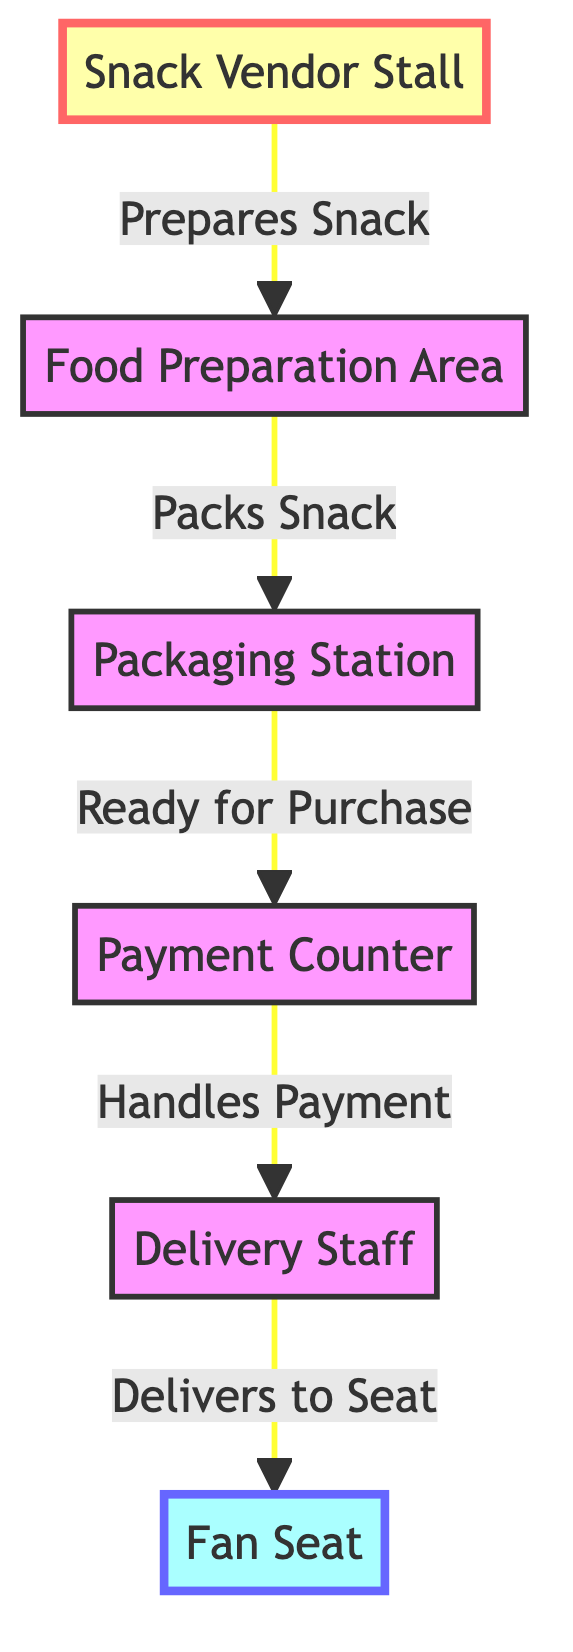What is the first step in the snack preparation process? The first step is "Prepares Snack," where the Snack Vendor Stall prepares the snack.
Answer: Prepares Snack How many nodes are in the diagram? The diagram consists of 6 nodes: Snack Vendor Stall, Food Preparation Area, Packaging Station, Payment Counter, Delivery Staff, and Fan Seat.
Answer: 6 What role does the Delivery Staff play in the process? The Delivery Staff's role is to "Delivers to Seat," referring to delivering the packed snack to the fan's seat.
Answer: Delivers to Seat What comes after the Packaging Station in the workflow? After the Packaging Station, the workflow leads to the Payment Counter, indicating the next step after packing.
Answer: Payment Counter What is the final destination in the snack journey? The final destination in the snack journey is the Fan Seat, where the fan receives the snack.
Answer: Fan Seat What is the relationship between the Vendor and the Food Preparation Area? The relationship is that the Vendor "Prepares Snack" in the Food Preparation Area, indicating a direct action from the vendor to this area.
Answer: Prepares Snack What is packaged before reaching the Payment Counter? The item that is packaged before reaching the Payment Counter is the snack, which is ready for purchase at that point.
Answer: Snack What does the diagram illustrate regarding matchday snacks? The diagram illustrates the flow of a matchday snack from preparation by the vendor to delivery to the fan's seat.
Answer: Flow of Snack How is payment handled in the snack preparation process? Payment is handled at the "Payment Counter," where the transaction occurs before delivery to the fan.
Answer: Payment Counter 